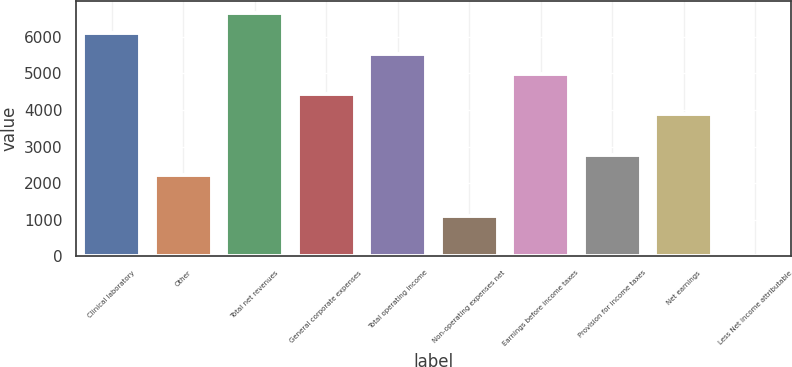<chart> <loc_0><loc_0><loc_500><loc_500><bar_chart><fcel>Clinical laboratory<fcel>Other<fcel>Total net revenues<fcel>General corporate expenses<fcel>Total operating income<fcel>Non-operating expenses net<fcel>Earnings before income taxes<fcel>Provision for income taxes<fcel>Net earnings<fcel>Less Net income attributable<nl><fcel>6095.19<fcel>2224.96<fcel>6648.08<fcel>4436.52<fcel>5542.3<fcel>1119.18<fcel>4989.41<fcel>2777.85<fcel>3883.63<fcel>13.4<nl></chart> 